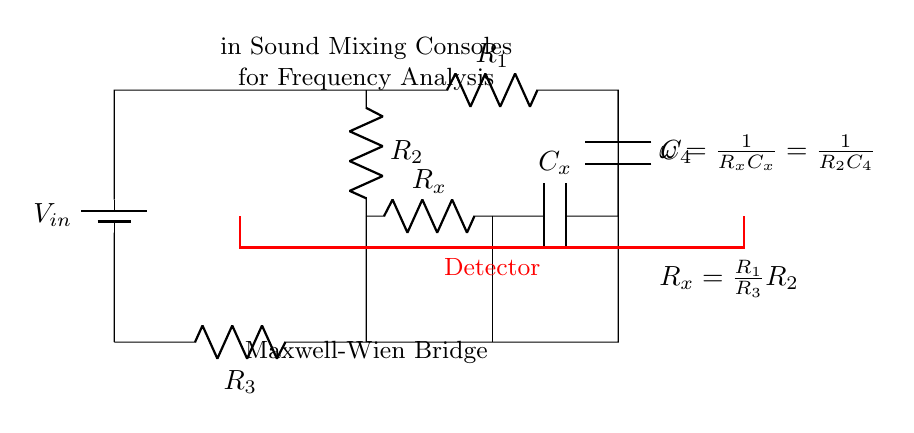What is the input voltage of the circuit? The input voltage is labeled as V_in, indicated by the battery symbol at the top left of the circuit diagram.
Answer: V_in What type of components are R_1, R_2, and R_3? R_1, R_2, and R_3 are resistors, which are common passive electrical components used to resist the flow of electric current. They are represented by the R symbol connected in series and parallel in the circuit.
Answer: Resistors What condition must be met for the bridge to be balanced? For the bridge to be balanced, the condition R_x must equal (R_1/R_3)R_2, as indicated by the equation given in the circuit diagram.
Answer: R_x = (R_1/R_3)R_2 How is the frequency related to the components in the circuit? The frequency, represented by omega (ω), is determined by the relationship ω = 1/(R_xC_x) = 1/(R_2C_4), indicating that the frequency directly depends on the resistances R_x, R_2, and capacitances C_x, C_4 within the circuit.
Answer: ω = 1/(R_xC_x) What is the purpose of the detector in the circuit? The detector, which is indicated in red in the circuit, is used to measure the output signal and determine whether the bridge is balanced or not, playing a crucial role in the frequency analysis aspect of the bridge.
Answer: Measure output signal What type of bridge is depicted in this circuit? The circuit represents a Maxwell-Wien bridge, a specific type of bridge circuit used for accurate frequency analysis in sound mixing consoles, as noted in the annotations of the diagram.
Answer: Maxwell-Wien Bridge 